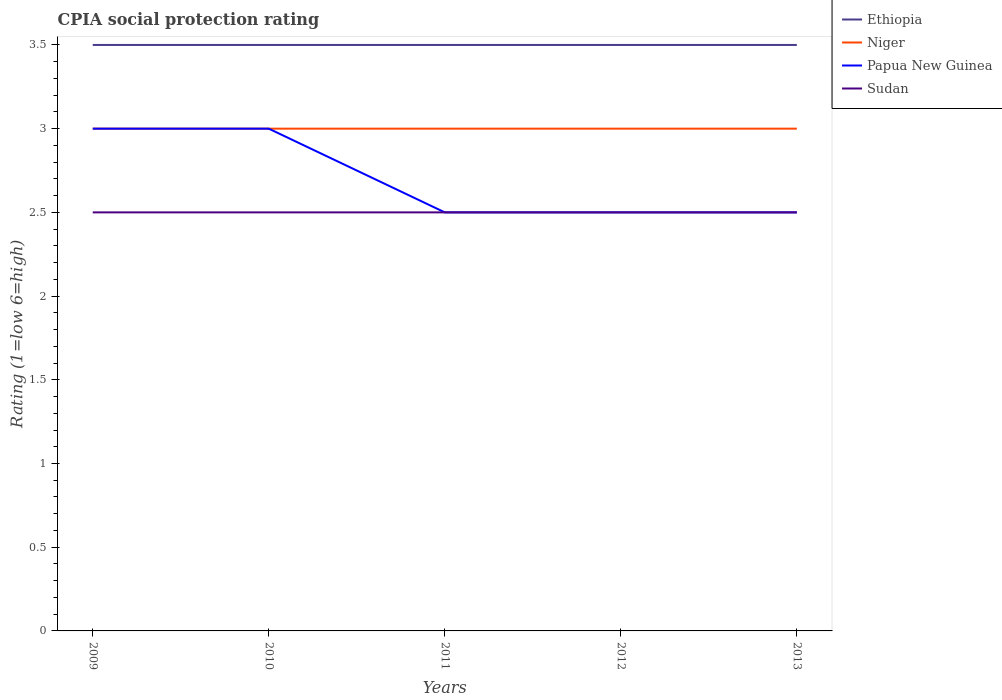Across all years, what is the maximum CPIA rating in Niger?
Provide a succinct answer. 3. What is the difference between the highest and the second highest CPIA rating in Niger?
Provide a short and direct response. 0. What is the difference between the highest and the lowest CPIA rating in Niger?
Give a very brief answer. 0. Is the CPIA rating in Ethiopia strictly greater than the CPIA rating in Niger over the years?
Provide a succinct answer. No. How many lines are there?
Your response must be concise. 4. What is the difference between two consecutive major ticks on the Y-axis?
Provide a succinct answer. 0.5. Are the values on the major ticks of Y-axis written in scientific E-notation?
Keep it short and to the point. No. Does the graph contain grids?
Your answer should be very brief. No. How many legend labels are there?
Keep it short and to the point. 4. What is the title of the graph?
Provide a succinct answer. CPIA social protection rating. What is the label or title of the X-axis?
Offer a terse response. Years. What is the label or title of the Y-axis?
Your answer should be compact. Rating (1=low 6=high). What is the Rating (1=low 6=high) in Ethiopia in 2009?
Your answer should be compact. 3.5. What is the Rating (1=low 6=high) of Papua New Guinea in 2009?
Offer a terse response. 3. What is the Rating (1=low 6=high) of Ethiopia in 2010?
Make the answer very short. 3.5. What is the Rating (1=low 6=high) in Niger in 2010?
Offer a terse response. 3. What is the Rating (1=low 6=high) in Papua New Guinea in 2010?
Your answer should be very brief. 3. What is the Rating (1=low 6=high) of Sudan in 2010?
Provide a short and direct response. 2.5. What is the Rating (1=low 6=high) of Sudan in 2011?
Your response must be concise. 2.5. What is the Rating (1=low 6=high) in Ethiopia in 2012?
Give a very brief answer. 3.5. What is the Rating (1=low 6=high) of Papua New Guinea in 2012?
Provide a succinct answer. 2.5. What is the Rating (1=low 6=high) of Sudan in 2012?
Ensure brevity in your answer.  2.5. What is the Rating (1=low 6=high) of Ethiopia in 2013?
Ensure brevity in your answer.  3.5. Across all years, what is the maximum Rating (1=low 6=high) of Niger?
Provide a short and direct response. 3. Across all years, what is the maximum Rating (1=low 6=high) in Sudan?
Your answer should be very brief. 2.5. Across all years, what is the minimum Rating (1=low 6=high) in Niger?
Offer a terse response. 3. Across all years, what is the minimum Rating (1=low 6=high) of Papua New Guinea?
Make the answer very short. 2.5. What is the total Rating (1=low 6=high) of Ethiopia in the graph?
Keep it short and to the point. 17.5. What is the difference between the Rating (1=low 6=high) of Niger in 2009 and that in 2010?
Provide a succinct answer. 0. What is the difference between the Rating (1=low 6=high) in Ethiopia in 2009 and that in 2011?
Your response must be concise. 0. What is the difference between the Rating (1=low 6=high) in Niger in 2009 and that in 2011?
Keep it short and to the point. 0. What is the difference between the Rating (1=low 6=high) of Papua New Guinea in 2009 and that in 2012?
Ensure brevity in your answer.  0.5. What is the difference between the Rating (1=low 6=high) of Sudan in 2009 and that in 2012?
Offer a terse response. 0. What is the difference between the Rating (1=low 6=high) in Niger in 2009 and that in 2013?
Make the answer very short. 0. What is the difference between the Rating (1=low 6=high) in Papua New Guinea in 2009 and that in 2013?
Provide a succinct answer. 0.5. What is the difference between the Rating (1=low 6=high) of Sudan in 2009 and that in 2013?
Provide a succinct answer. 0. What is the difference between the Rating (1=low 6=high) of Ethiopia in 2010 and that in 2011?
Your answer should be very brief. 0. What is the difference between the Rating (1=low 6=high) of Niger in 2010 and that in 2011?
Provide a short and direct response. 0. What is the difference between the Rating (1=low 6=high) of Papua New Guinea in 2010 and that in 2011?
Ensure brevity in your answer.  0.5. What is the difference between the Rating (1=low 6=high) in Sudan in 2010 and that in 2011?
Your answer should be very brief. 0. What is the difference between the Rating (1=low 6=high) in Sudan in 2010 and that in 2012?
Provide a succinct answer. 0. What is the difference between the Rating (1=low 6=high) in Ethiopia in 2010 and that in 2013?
Make the answer very short. 0. What is the difference between the Rating (1=low 6=high) in Niger in 2010 and that in 2013?
Offer a terse response. 0. What is the difference between the Rating (1=low 6=high) in Papua New Guinea in 2010 and that in 2013?
Offer a very short reply. 0.5. What is the difference between the Rating (1=low 6=high) of Sudan in 2010 and that in 2013?
Offer a very short reply. 0. What is the difference between the Rating (1=low 6=high) of Papua New Guinea in 2011 and that in 2012?
Offer a very short reply. 0. What is the difference between the Rating (1=low 6=high) in Papua New Guinea in 2011 and that in 2013?
Your answer should be compact. 0. What is the difference between the Rating (1=low 6=high) of Sudan in 2011 and that in 2013?
Provide a succinct answer. 0. What is the difference between the Rating (1=low 6=high) of Niger in 2012 and that in 2013?
Give a very brief answer. 0. What is the difference between the Rating (1=low 6=high) of Niger in 2009 and the Rating (1=low 6=high) of Papua New Guinea in 2010?
Keep it short and to the point. 0. What is the difference between the Rating (1=low 6=high) of Ethiopia in 2009 and the Rating (1=low 6=high) of Papua New Guinea in 2011?
Offer a terse response. 1. What is the difference between the Rating (1=low 6=high) in Niger in 2009 and the Rating (1=low 6=high) in Papua New Guinea in 2011?
Your answer should be compact. 0.5. What is the difference between the Rating (1=low 6=high) in Niger in 2009 and the Rating (1=low 6=high) in Sudan in 2011?
Your response must be concise. 0.5. What is the difference between the Rating (1=low 6=high) in Ethiopia in 2009 and the Rating (1=low 6=high) in Niger in 2012?
Offer a terse response. 0.5. What is the difference between the Rating (1=low 6=high) in Ethiopia in 2009 and the Rating (1=low 6=high) in Niger in 2013?
Ensure brevity in your answer.  0.5. What is the difference between the Rating (1=low 6=high) of Niger in 2009 and the Rating (1=low 6=high) of Sudan in 2013?
Provide a short and direct response. 0.5. What is the difference between the Rating (1=low 6=high) in Papua New Guinea in 2009 and the Rating (1=low 6=high) in Sudan in 2013?
Make the answer very short. 0.5. What is the difference between the Rating (1=low 6=high) of Ethiopia in 2010 and the Rating (1=low 6=high) of Niger in 2011?
Keep it short and to the point. 0.5. What is the difference between the Rating (1=low 6=high) of Ethiopia in 2010 and the Rating (1=low 6=high) of Papua New Guinea in 2011?
Your answer should be compact. 1. What is the difference between the Rating (1=low 6=high) of Ethiopia in 2010 and the Rating (1=low 6=high) of Sudan in 2011?
Make the answer very short. 1. What is the difference between the Rating (1=low 6=high) of Ethiopia in 2010 and the Rating (1=low 6=high) of Papua New Guinea in 2012?
Make the answer very short. 1. What is the difference between the Rating (1=low 6=high) in Ethiopia in 2010 and the Rating (1=low 6=high) in Niger in 2013?
Provide a short and direct response. 0.5. What is the difference between the Rating (1=low 6=high) of Ethiopia in 2010 and the Rating (1=low 6=high) of Sudan in 2013?
Ensure brevity in your answer.  1. What is the difference between the Rating (1=low 6=high) of Niger in 2010 and the Rating (1=low 6=high) of Papua New Guinea in 2013?
Your answer should be compact. 0.5. What is the difference between the Rating (1=low 6=high) of Niger in 2010 and the Rating (1=low 6=high) of Sudan in 2013?
Give a very brief answer. 0.5. What is the difference between the Rating (1=low 6=high) in Ethiopia in 2011 and the Rating (1=low 6=high) in Niger in 2012?
Provide a succinct answer. 0.5. What is the difference between the Rating (1=low 6=high) in Ethiopia in 2011 and the Rating (1=low 6=high) in Papua New Guinea in 2013?
Make the answer very short. 1. What is the difference between the Rating (1=low 6=high) of Papua New Guinea in 2011 and the Rating (1=low 6=high) of Sudan in 2013?
Give a very brief answer. 0. What is the difference between the Rating (1=low 6=high) of Ethiopia in 2012 and the Rating (1=low 6=high) of Niger in 2013?
Your response must be concise. 0.5. What is the difference between the Rating (1=low 6=high) of Niger in 2012 and the Rating (1=low 6=high) of Sudan in 2013?
Provide a short and direct response. 0.5. What is the difference between the Rating (1=low 6=high) in Papua New Guinea in 2012 and the Rating (1=low 6=high) in Sudan in 2013?
Provide a succinct answer. 0. What is the average Rating (1=low 6=high) in Papua New Guinea per year?
Your answer should be very brief. 2.7. In the year 2009, what is the difference between the Rating (1=low 6=high) in Niger and Rating (1=low 6=high) in Papua New Guinea?
Your response must be concise. 0. In the year 2009, what is the difference between the Rating (1=low 6=high) of Niger and Rating (1=low 6=high) of Sudan?
Your answer should be compact. 0.5. In the year 2010, what is the difference between the Rating (1=low 6=high) of Ethiopia and Rating (1=low 6=high) of Niger?
Offer a terse response. 0.5. In the year 2010, what is the difference between the Rating (1=low 6=high) in Ethiopia and Rating (1=low 6=high) in Sudan?
Give a very brief answer. 1. In the year 2010, what is the difference between the Rating (1=low 6=high) in Niger and Rating (1=low 6=high) in Papua New Guinea?
Your answer should be very brief. 0. In the year 2010, what is the difference between the Rating (1=low 6=high) of Niger and Rating (1=low 6=high) of Sudan?
Provide a short and direct response. 0.5. In the year 2010, what is the difference between the Rating (1=low 6=high) of Papua New Guinea and Rating (1=low 6=high) of Sudan?
Ensure brevity in your answer.  0.5. In the year 2011, what is the difference between the Rating (1=low 6=high) of Ethiopia and Rating (1=low 6=high) of Papua New Guinea?
Offer a terse response. 1. In the year 2011, what is the difference between the Rating (1=low 6=high) in Ethiopia and Rating (1=low 6=high) in Sudan?
Your answer should be very brief. 1. In the year 2012, what is the difference between the Rating (1=low 6=high) of Ethiopia and Rating (1=low 6=high) of Papua New Guinea?
Offer a terse response. 1. In the year 2012, what is the difference between the Rating (1=low 6=high) of Niger and Rating (1=low 6=high) of Sudan?
Offer a terse response. 0.5. In the year 2013, what is the difference between the Rating (1=low 6=high) of Ethiopia and Rating (1=low 6=high) of Niger?
Give a very brief answer. 0.5. In the year 2013, what is the difference between the Rating (1=low 6=high) in Ethiopia and Rating (1=low 6=high) in Papua New Guinea?
Ensure brevity in your answer.  1. In the year 2013, what is the difference between the Rating (1=low 6=high) of Niger and Rating (1=low 6=high) of Papua New Guinea?
Ensure brevity in your answer.  0.5. In the year 2013, what is the difference between the Rating (1=low 6=high) of Niger and Rating (1=low 6=high) of Sudan?
Your answer should be very brief. 0.5. What is the ratio of the Rating (1=low 6=high) in Ethiopia in 2009 to that in 2010?
Your answer should be compact. 1. What is the ratio of the Rating (1=low 6=high) of Papua New Guinea in 2009 to that in 2010?
Make the answer very short. 1. What is the ratio of the Rating (1=low 6=high) in Ethiopia in 2009 to that in 2011?
Offer a terse response. 1. What is the ratio of the Rating (1=low 6=high) in Niger in 2009 to that in 2011?
Your response must be concise. 1. What is the ratio of the Rating (1=low 6=high) of Papua New Guinea in 2009 to that in 2011?
Offer a very short reply. 1.2. What is the ratio of the Rating (1=low 6=high) in Sudan in 2009 to that in 2011?
Provide a succinct answer. 1. What is the ratio of the Rating (1=low 6=high) of Papua New Guinea in 2009 to that in 2012?
Ensure brevity in your answer.  1.2. What is the ratio of the Rating (1=low 6=high) in Sudan in 2009 to that in 2012?
Your answer should be very brief. 1. What is the ratio of the Rating (1=low 6=high) in Ethiopia in 2009 to that in 2013?
Provide a short and direct response. 1. What is the ratio of the Rating (1=low 6=high) of Sudan in 2009 to that in 2013?
Offer a terse response. 1. What is the ratio of the Rating (1=low 6=high) in Ethiopia in 2010 to that in 2011?
Offer a very short reply. 1. What is the ratio of the Rating (1=low 6=high) in Niger in 2010 to that in 2011?
Your answer should be very brief. 1. What is the ratio of the Rating (1=low 6=high) of Ethiopia in 2010 to that in 2012?
Ensure brevity in your answer.  1. What is the ratio of the Rating (1=low 6=high) in Niger in 2010 to that in 2012?
Offer a very short reply. 1. What is the ratio of the Rating (1=low 6=high) in Papua New Guinea in 2010 to that in 2012?
Your response must be concise. 1.2. What is the ratio of the Rating (1=low 6=high) of Sudan in 2010 to that in 2012?
Your response must be concise. 1. What is the ratio of the Rating (1=low 6=high) in Ethiopia in 2010 to that in 2013?
Your answer should be compact. 1. What is the ratio of the Rating (1=low 6=high) in Niger in 2010 to that in 2013?
Give a very brief answer. 1. What is the ratio of the Rating (1=low 6=high) of Papua New Guinea in 2010 to that in 2013?
Provide a succinct answer. 1.2. What is the ratio of the Rating (1=low 6=high) of Niger in 2011 to that in 2012?
Provide a short and direct response. 1. What is the ratio of the Rating (1=low 6=high) of Papua New Guinea in 2011 to that in 2012?
Give a very brief answer. 1. What is the ratio of the Rating (1=low 6=high) of Sudan in 2011 to that in 2012?
Offer a terse response. 1. What is the ratio of the Rating (1=low 6=high) of Ethiopia in 2011 to that in 2013?
Offer a very short reply. 1. What is the ratio of the Rating (1=low 6=high) of Papua New Guinea in 2011 to that in 2013?
Ensure brevity in your answer.  1. What is the ratio of the Rating (1=low 6=high) in Sudan in 2011 to that in 2013?
Make the answer very short. 1. What is the ratio of the Rating (1=low 6=high) in Ethiopia in 2012 to that in 2013?
Your response must be concise. 1. What is the ratio of the Rating (1=low 6=high) of Papua New Guinea in 2012 to that in 2013?
Provide a succinct answer. 1. What is the difference between the highest and the second highest Rating (1=low 6=high) of Niger?
Offer a very short reply. 0. What is the difference between the highest and the lowest Rating (1=low 6=high) of Ethiopia?
Keep it short and to the point. 0. What is the difference between the highest and the lowest Rating (1=low 6=high) in Niger?
Provide a short and direct response. 0. What is the difference between the highest and the lowest Rating (1=low 6=high) of Papua New Guinea?
Make the answer very short. 0.5. 